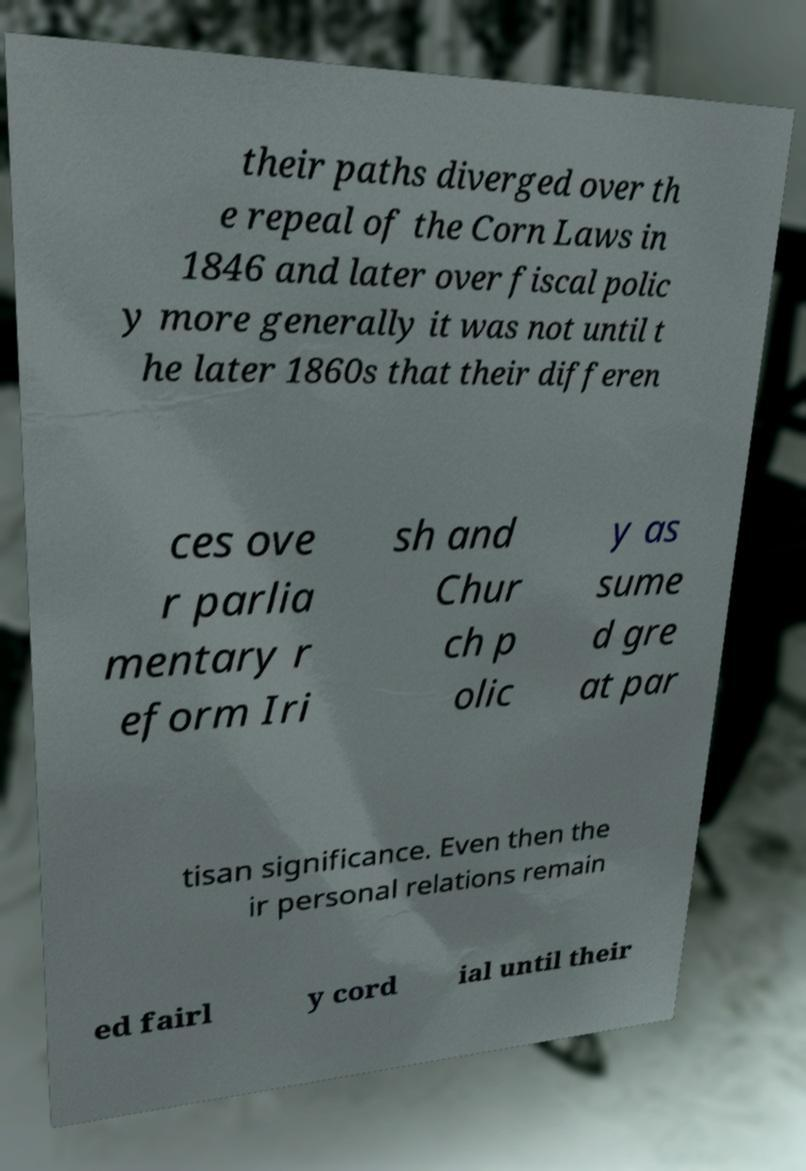I need the written content from this picture converted into text. Can you do that? their paths diverged over th e repeal of the Corn Laws in 1846 and later over fiscal polic y more generally it was not until t he later 1860s that their differen ces ove r parlia mentary r eform Iri sh and Chur ch p olic y as sume d gre at par tisan significance. Even then the ir personal relations remain ed fairl y cord ial until their 